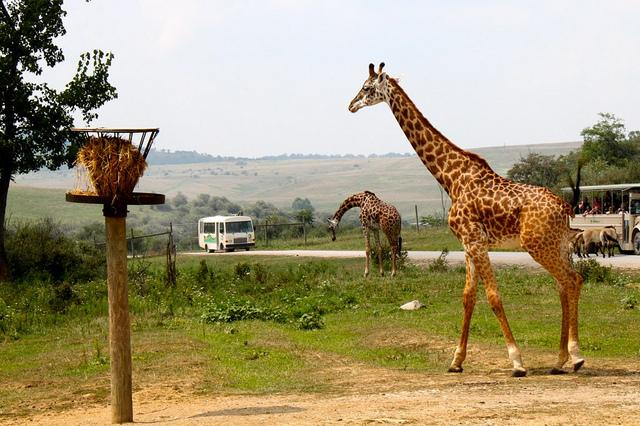What are the people on the vehicle to the right involved in? Please explain your reasoning. safari. The people are watching the giraffes. 